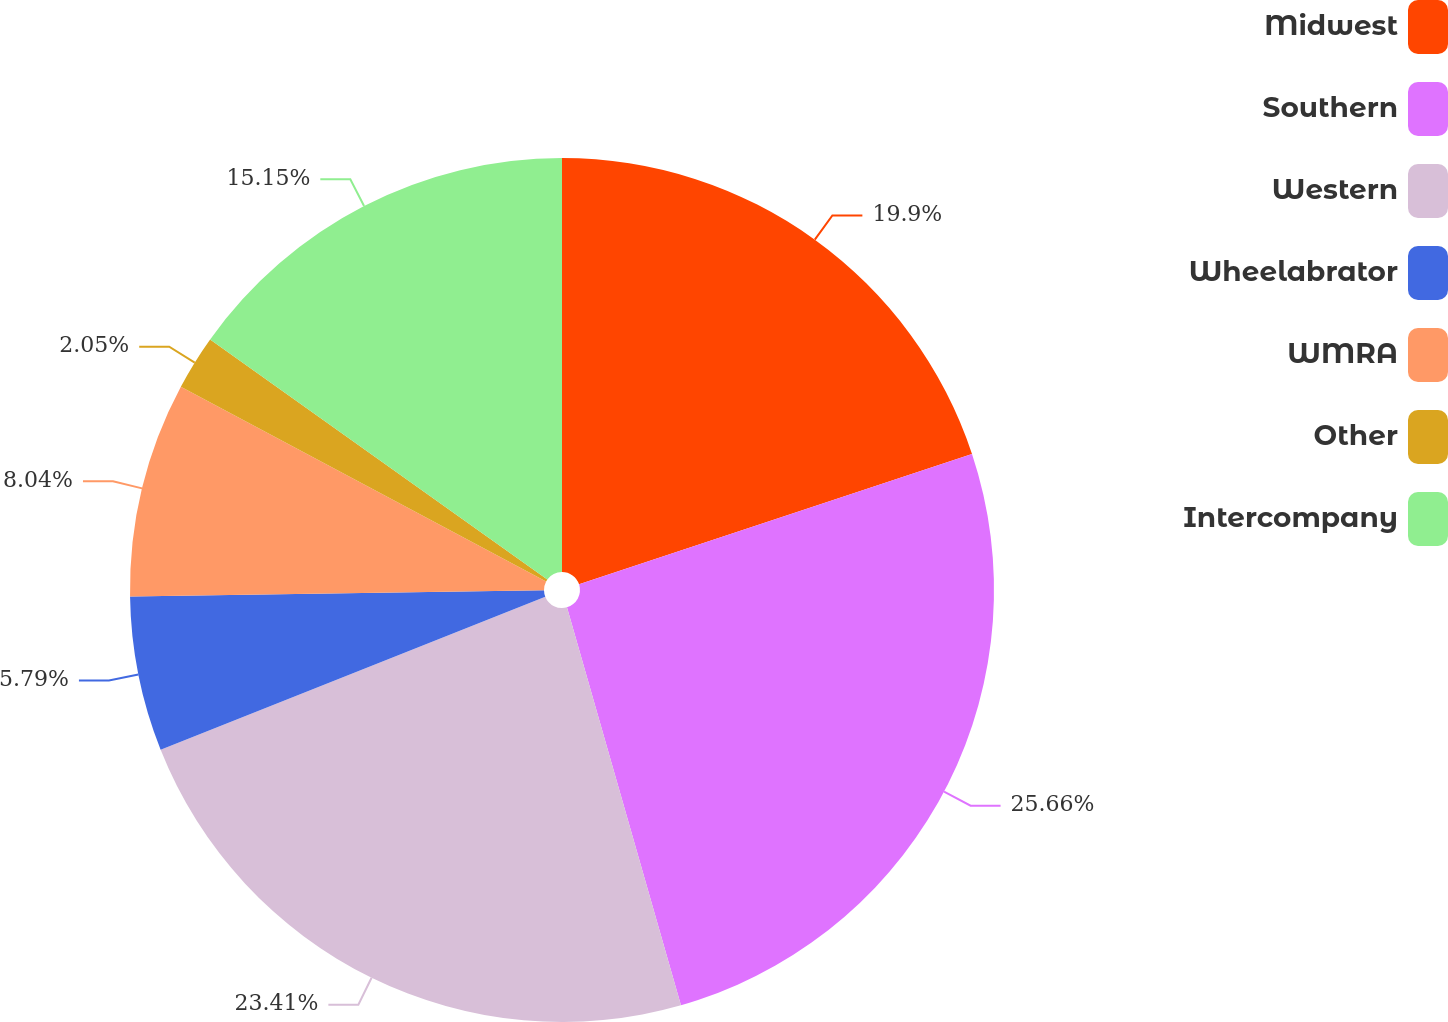Convert chart. <chart><loc_0><loc_0><loc_500><loc_500><pie_chart><fcel>Midwest<fcel>Southern<fcel>Western<fcel>Wheelabrator<fcel>WMRA<fcel>Other<fcel>Intercompany<nl><fcel>19.9%<fcel>25.66%<fcel>23.41%<fcel>5.79%<fcel>8.04%<fcel>2.05%<fcel>15.15%<nl></chart> 